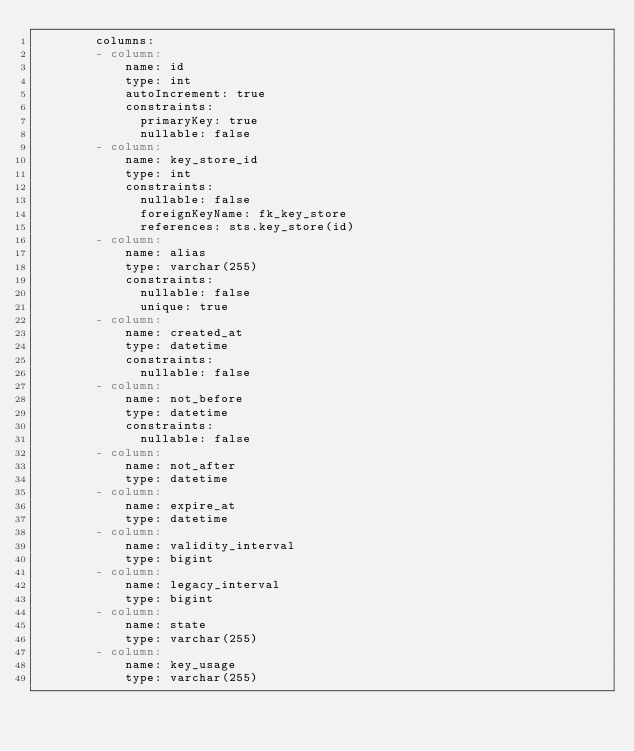Convert code to text. <code><loc_0><loc_0><loc_500><loc_500><_YAML_>        columns:
        - column:
            name: id
            type: int
            autoIncrement: true
            constraints:
              primaryKey: true
              nullable: false
        - column:
            name: key_store_id
            type: int
            constraints:
              nullable: false
              foreignKeyName: fk_key_store
              references: sts.key_store(id)
        - column:
            name: alias
            type: varchar(255)
            constraints:
              nullable: false
              unique: true
        - column:
            name: created_at
            type: datetime
            constraints:
              nullable: false
        - column:
            name: not_before
            type: datetime
            constraints:
              nullable: false
        - column:
            name: not_after
            type: datetime
        - column:
            name: expire_at
            type: datetime
        - column:
            name: validity_interval
            type: bigint
        - column:
            name: legacy_interval
            type: bigint
        - column:
            name: state
            type: varchar(255)
        - column:
            name: key_usage
            type: varchar(255)
</code> 